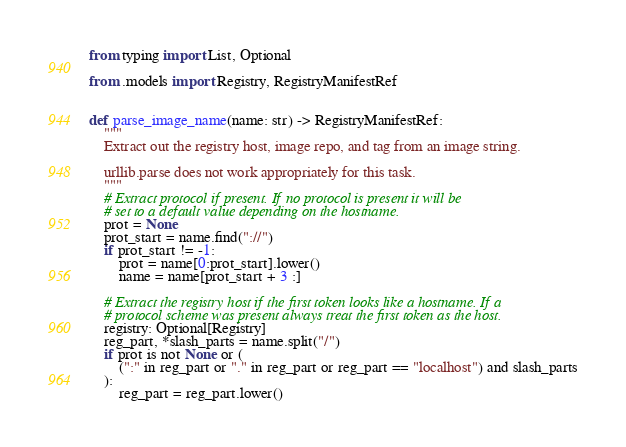<code> <loc_0><loc_0><loc_500><loc_500><_Python_>from typing import List, Optional

from .models import Registry, RegistryManifestRef


def parse_image_name(name: str) -> RegistryManifestRef:
    """
    Extract out the registry host, image repo, and tag from an image string.

    urllib.parse does not work appropriately for this task.
    """
    # Extract protocol if present. If no protocol is present it will be
    # set to a default value depending on the hostname.
    prot = None
    prot_start = name.find("://")
    if prot_start != -1:
        prot = name[0:prot_start].lower()
        name = name[prot_start + 3 :]

    # Extract the registry host if the first token looks like a hostname. If a
    # protocol scheme was present always treat the first token as the host.
    registry: Optional[Registry]
    reg_part, *slash_parts = name.split("/")
    if prot is not None or (
        (":" in reg_part or "." in reg_part or reg_part == "localhost") and slash_parts
    ):
        reg_part = reg_part.lower()</code> 